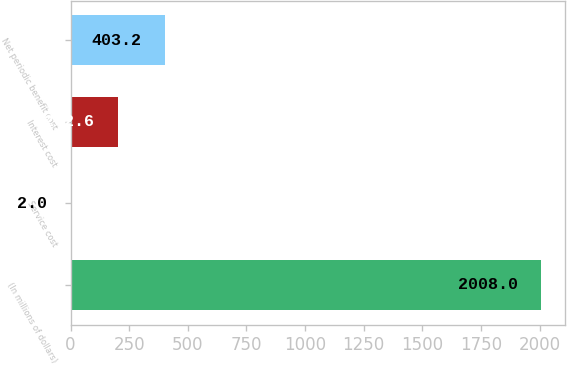Convert chart to OTSL. <chart><loc_0><loc_0><loc_500><loc_500><bar_chart><fcel>(In millions of dollars)<fcel>Service cost<fcel>Interest cost<fcel>Net periodic benefit cost<nl><fcel>2008<fcel>2<fcel>202.6<fcel>403.2<nl></chart> 